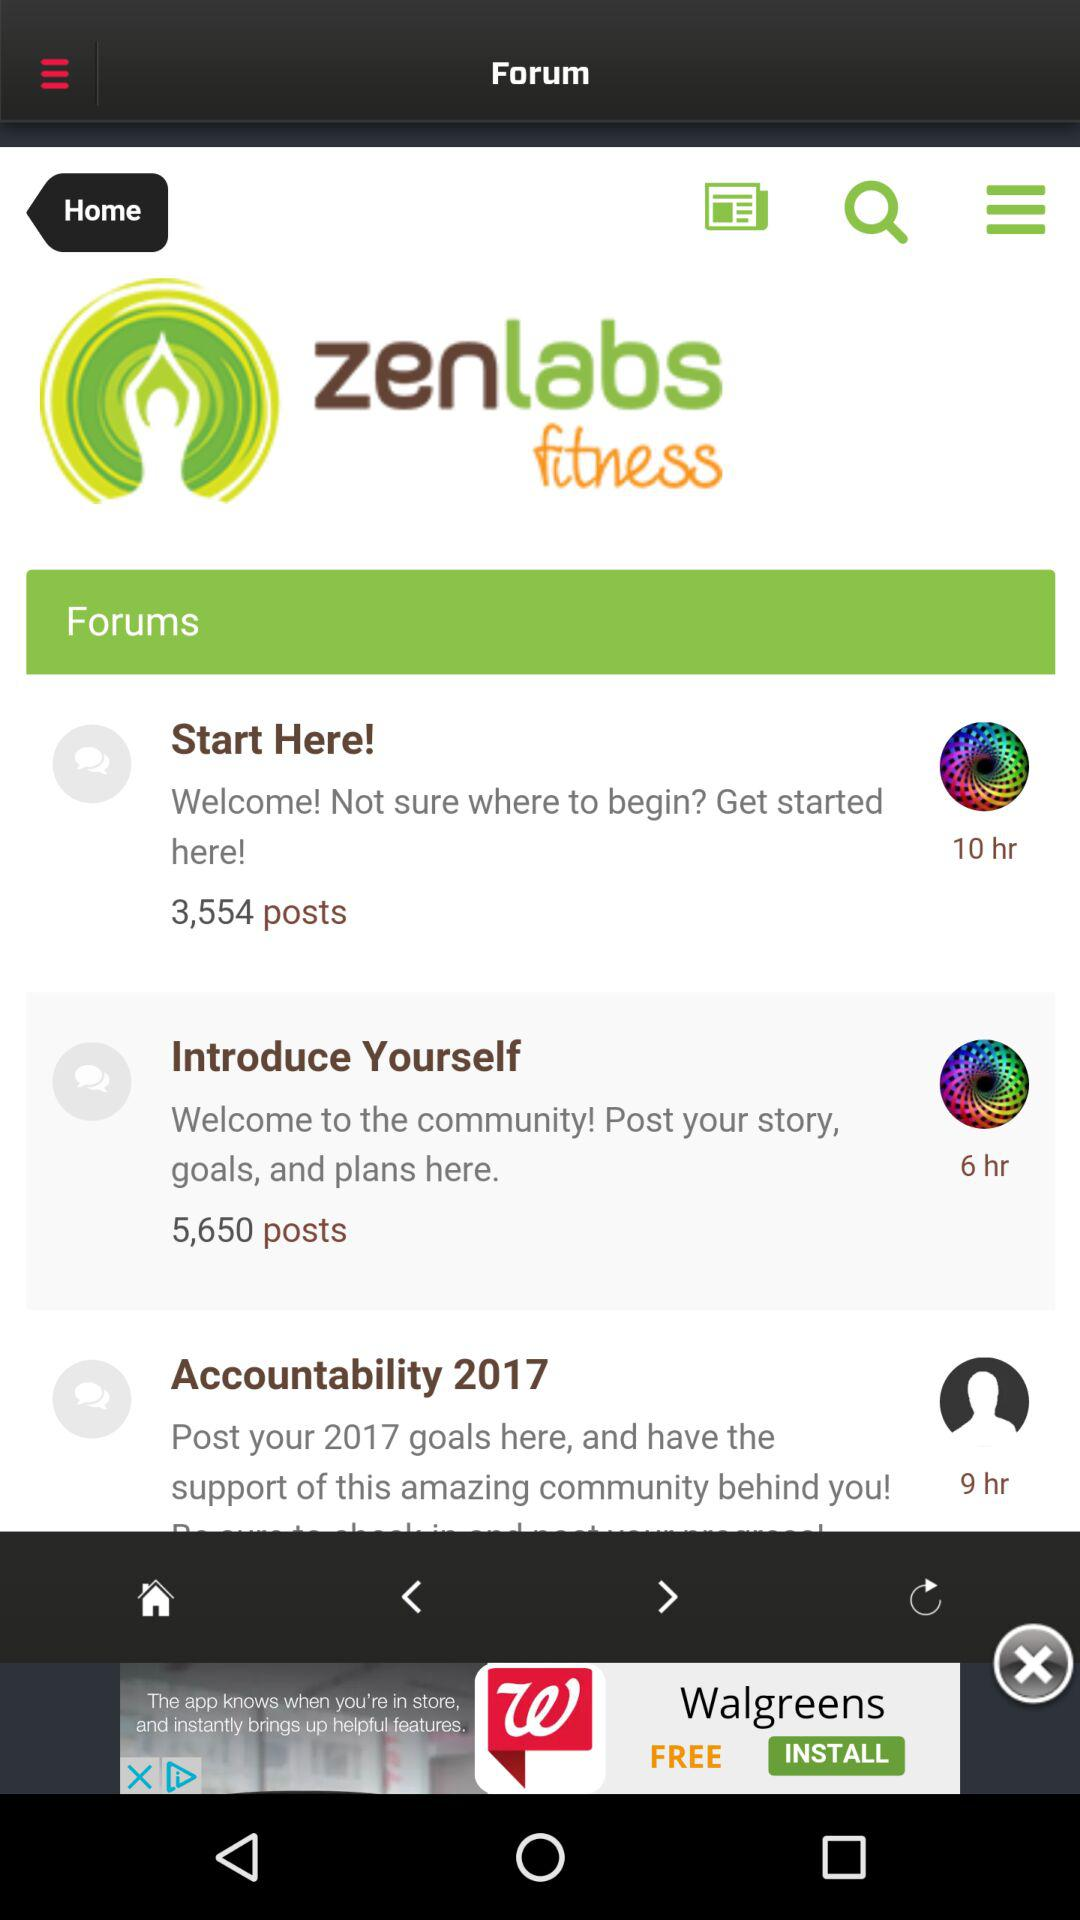What is the developer name? The developer name is Zen Labs Fitness. 